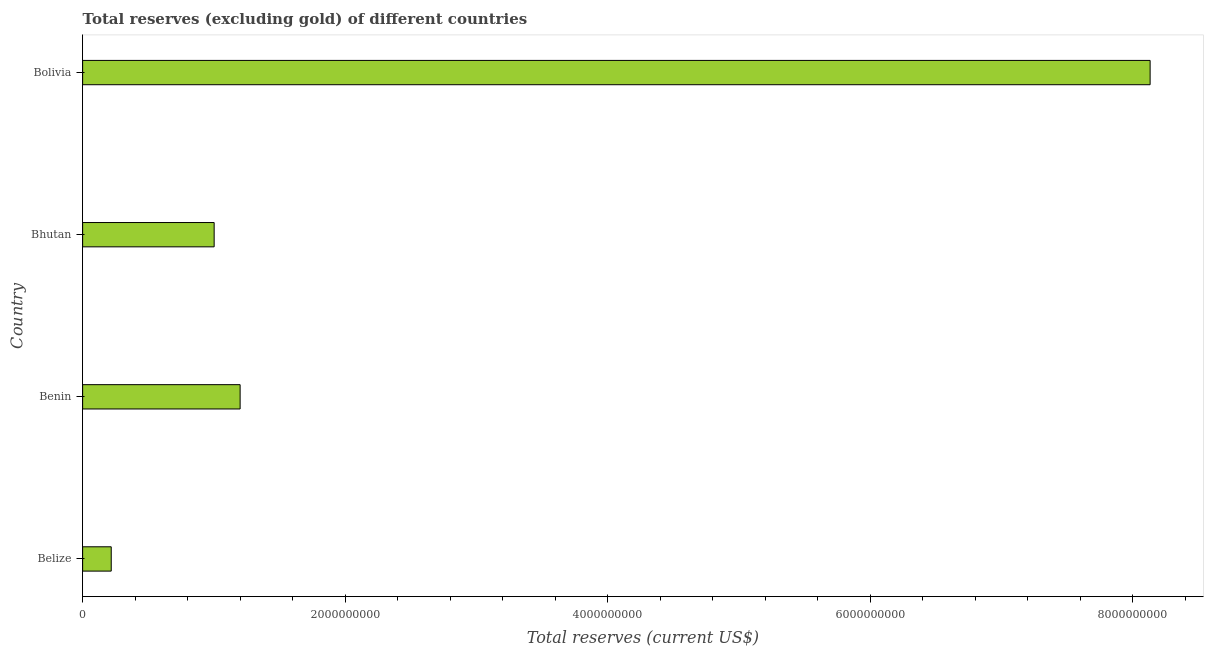Does the graph contain grids?
Provide a short and direct response. No. What is the title of the graph?
Keep it short and to the point. Total reserves (excluding gold) of different countries. What is the label or title of the X-axis?
Provide a short and direct response. Total reserves (current US$). What is the label or title of the Y-axis?
Make the answer very short. Country. What is the total reserves (excluding gold) in Belize?
Your response must be concise. 2.18e+08. Across all countries, what is the maximum total reserves (excluding gold)?
Provide a short and direct response. 8.13e+09. Across all countries, what is the minimum total reserves (excluding gold)?
Give a very brief answer. 2.18e+08. In which country was the total reserves (excluding gold) maximum?
Offer a terse response. Bolivia. In which country was the total reserves (excluding gold) minimum?
Your answer should be very brief. Belize. What is the sum of the total reserves (excluding gold)?
Provide a succinct answer. 1.06e+1. What is the difference between the total reserves (excluding gold) in Bhutan and Bolivia?
Keep it short and to the point. -7.13e+09. What is the average total reserves (excluding gold) per country?
Your answer should be very brief. 2.64e+09. What is the median total reserves (excluding gold)?
Offer a very short reply. 1.10e+09. In how many countries, is the total reserves (excluding gold) greater than 2400000000 US$?
Keep it short and to the point. 1. What is the ratio of the total reserves (excluding gold) in Benin to that in Bhutan?
Offer a terse response. 1.2. Is the total reserves (excluding gold) in Belize less than that in Benin?
Make the answer very short. Yes. What is the difference between the highest and the second highest total reserves (excluding gold)?
Your response must be concise. 6.93e+09. What is the difference between the highest and the lowest total reserves (excluding gold)?
Your response must be concise. 7.92e+09. How many bars are there?
Give a very brief answer. 4. How many countries are there in the graph?
Keep it short and to the point. 4. Are the values on the major ticks of X-axis written in scientific E-notation?
Give a very brief answer. No. What is the Total reserves (current US$) in Belize?
Keep it short and to the point. 2.18e+08. What is the Total reserves (current US$) of Benin?
Offer a very short reply. 1.20e+09. What is the Total reserves (current US$) in Bhutan?
Your response must be concise. 1.00e+09. What is the Total reserves (current US$) in Bolivia?
Keep it short and to the point. 8.13e+09. What is the difference between the Total reserves (current US$) in Belize and Benin?
Provide a short and direct response. -9.82e+08. What is the difference between the Total reserves (current US$) in Belize and Bhutan?
Ensure brevity in your answer.  -7.84e+08. What is the difference between the Total reserves (current US$) in Belize and Bolivia?
Provide a succinct answer. -7.92e+09. What is the difference between the Total reserves (current US$) in Benin and Bhutan?
Offer a very short reply. 1.98e+08. What is the difference between the Total reserves (current US$) in Benin and Bolivia?
Offer a terse response. -6.93e+09. What is the difference between the Total reserves (current US$) in Bhutan and Bolivia?
Provide a succinct answer. -7.13e+09. What is the ratio of the Total reserves (current US$) in Belize to that in Benin?
Keep it short and to the point. 0.18. What is the ratio of the Total reserves (current US$) in Belize to that in Bhutan?
Provide a succinct answer. 0.22. What is the ratio of the Total reserves (current US$) in Belize to that in Bolivia?
Offer a very short reply. 0.03. What is the ratio of the Total reserves (current US$) in Benin to that in Bhutan?
Provide a succinct answer. 1.2. What is the ratio of the Total reserves (current US$) in Benin to that in Bolivia?
Give a very brief answer. 0.15. What is the ratio of the Total reserves (current US$) in Bhutan to that in Bolivia?
Offer a very short reply. 0.12. 